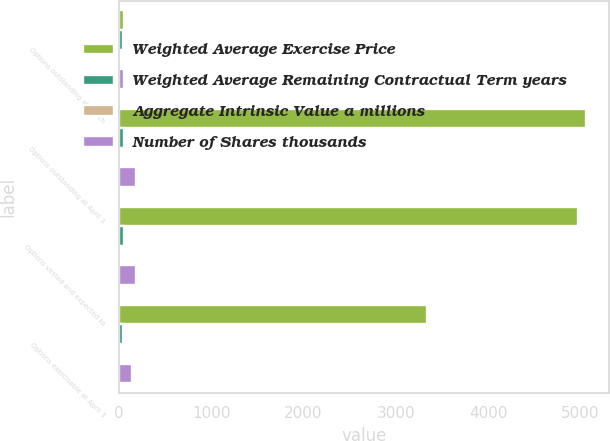<chart> <loc_0><loc_0><loc_500><loc_500><stacked_bar_chart><ecel><fcel>Options outstanding at March<fcel>Options outstanding at April 3<fcel>Options vested and expected to<fcel>Options exercisable at April 3<nl><fcel>Weighted Average Exercise Price<fcel>50.46<fcel>5055<fcel>4978<fcel>3340<nl><fcel>Weighted Average Remaining Contractual Term years<fcel>44.22<fcel>50.55<fcel>50.46<fcel>44.51<nl><fcel>Aggregate Intrinsic Value a millions<fcel>4.8<fcel>4.6<fcel>4.6<fcel>3.9<nl><fcel>Number of Shares thousands<fcel>50<fcel>188.6<fcel>186.3<fcel>144.9<nl></chart> 